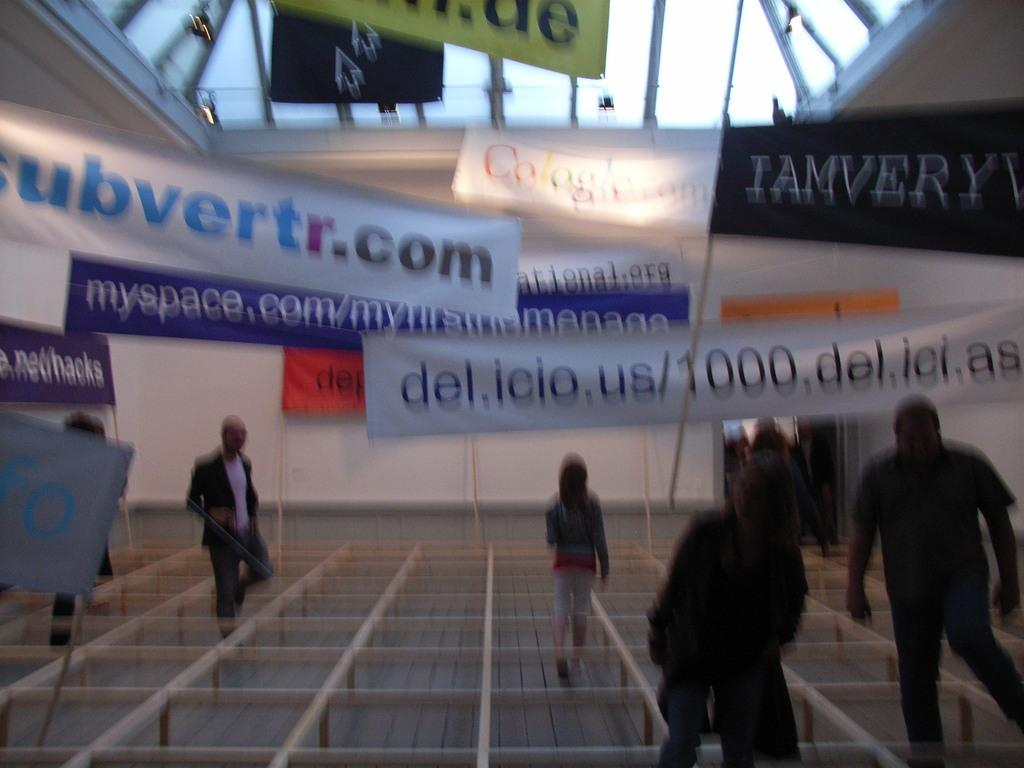What type of objects are made with wooden sticks in the image? There are blocks made with wooden sticks in the image. What are people doing in relation to the blocks in the image? People are moving through the blocks in the image. What additional decorative elements are present around the blocks in the image? There are banners around the blocks in the image. What type of channel can be seen in the image? There is no channel present in the image; it features blocks made with wooden sticks and people moving through them. Can you describe the farmer's technique for kissing in the image? There is no farmer or kissing depicted in the image. 